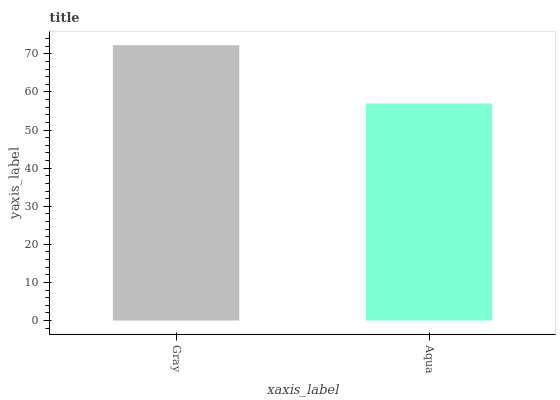Is Aqua the minimum?
Answer yes or no. Yes. Is Gray the maximum?
Answer yes or no. Yes. Is Aqua the maximum?
Answer yes or no. No. Is Gray greater than Aqua?
Answer yes or no. Yes. Is Aqua less than Gray?
Answer yes or no. Yes. Is Aqua greater than Gray?
Answer yes or no. No. Is Gray less than Aqua?
Answer yes or no. No. Is Gray the high median?
Answer yes or no. Yes. Is Aqua the low median?
Answer yes or no. Yes. Is Aqua the high median?
Answer yes or no. No. Is Gray the low median?
Answer yes or no. No. 